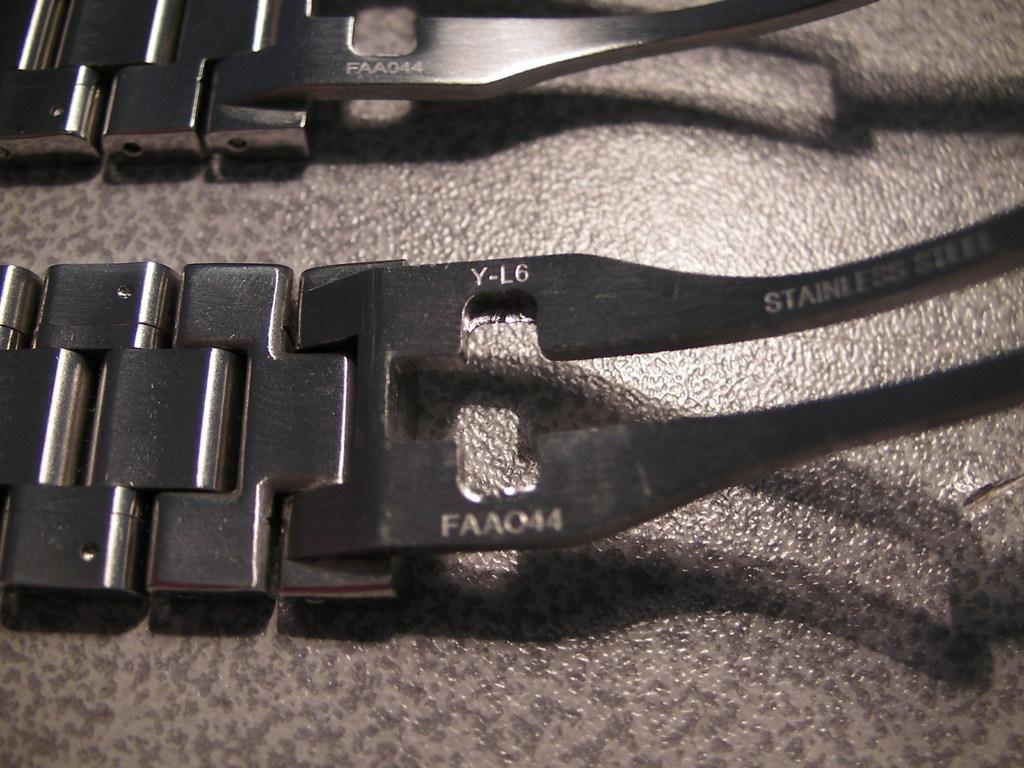What type of accessory is shown in the image? There are watch belts in the image. Where are the watch belts located? The watch belts are placed on a table. What type of honey is being used to fuel the war in the image? There is no war or honey present in the image; it only features watch belts placed on a table. 